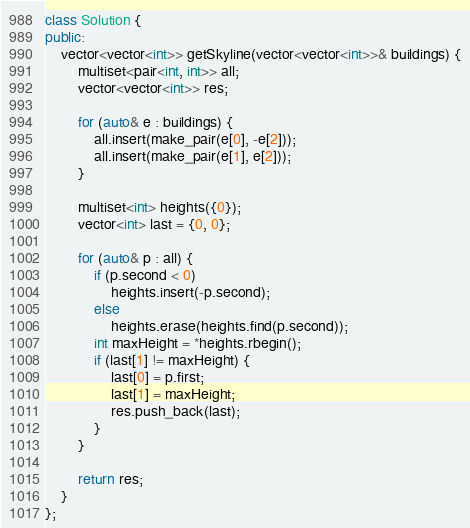Convert code to text. <code><loc_0><loc_0><loc_500><loc_500><_C++_>class Solution {
public:
    vector<vector<int>> getSkyline(vector<vector<int>>& buildings) {
        multiset<pair<int, int>> all;
        vector<vector<int>> res;
        
        for (auto& e : buildings) {
            all.insert(make_pair(e[0], -e[2]));
            all.insert(make_pair(e[1], e[2]));
        }

        multiset<int> heights({0});
        vector<int> last = {0, 0};

        for (auto& p : all) {
            if (p.second < 0)
                heights.insert(-p.second);
            else
                heights.erase(heights.find(p.second));
            int maxHeight = *heights.rbegin();
            if (last[1] != maxHeight) {
                last[0] = p.first;
                last[1] = maxHeight;
                res.push_back(last);
            }
        }

        return res;
    }
};
</code> 